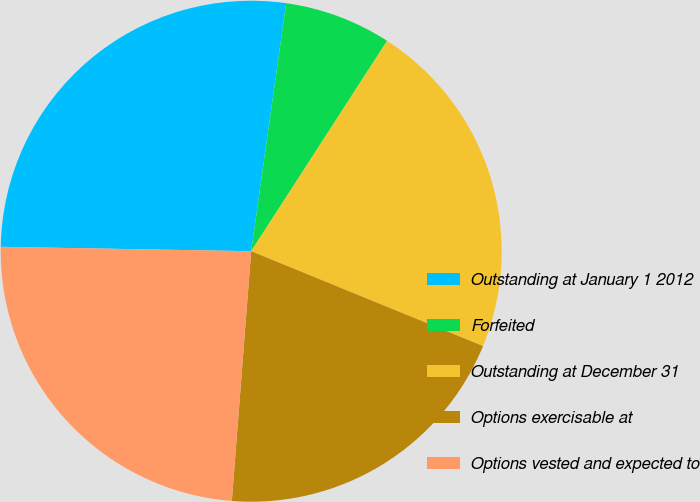Convert chart. <chart><loc_0><loc_0><loc_500><loc_500><pie_chart><fcel>Outstanding at January 1 2012<fcel>Forfeited<fcel>Outstanding at December 31<fcel>Options exercisable at<fcel>Options vested and expected to<nl><fcel>26.95%<fcel>6.9%<fcel>22.05%<fcel>20.05%<fcel>24.05%<nl></chart> 